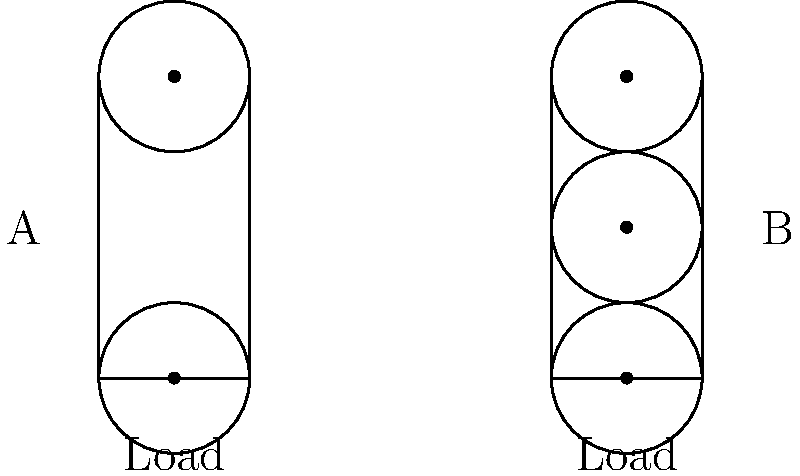As a sculptor familiar with rigging systems, compare the mechanical advantage of pulley systems A and B shown in the diagram. If both systems are lifting the same load, which system requires less force to lift the load, and what is its mechanical advantage? To solve this problem, let's analyze each pulley system:

1. System A:
   - This is a single movable pulley system.
   - The mechanical advantage (MA) for a single movable pulley is 2.
   - Force required = Load / 2

2. System B:
   - This is a compound pulley system with two movable pulleys.
   - For each movable pulley, the mechanical advantage doubles.
   - MA = $2^n$, where n is the number of movable pulleys.
   - In this case, MA = $2^2 = 4$
   - Force required = Load / 4

3. Comparing the two systems:
   - System B has a higher mechanical advantage (4 vs 2).
   - This means System B requires less force to lift the same load.

4. Calculating the difference:
   - System A requires Load/2 force
   - System B requires Load/4 force
   - System B requires half the force of System A

Therefore, System B requires less force to lift the load and has a mechanical advantage of 4.
Answer: System B; MA = 4 